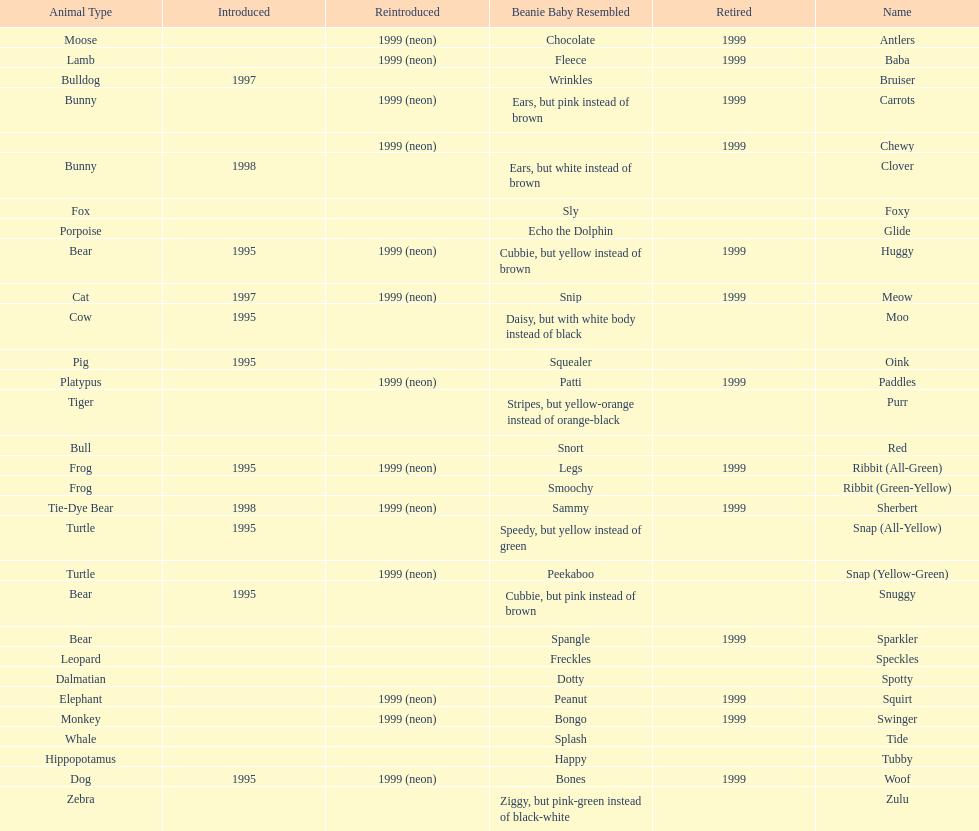What is the name of the last pillow pal on this chart? Zulu. 